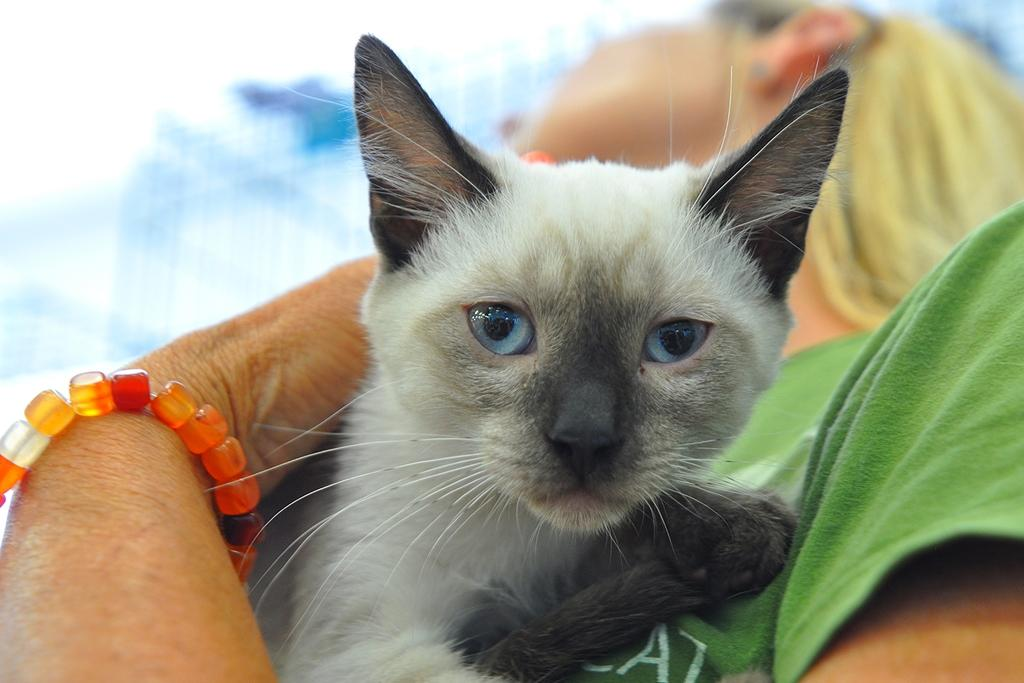What type of animal is in the picture? There is a white color cat in the picture. What is the cat doing in the picture? The cat is looking into the camera. Who is holding the cat in the picture? The cat is being held by a girl. How would you describe the background in the picture? The background in the picture is blurred. What type of doctor is attending to the nation in the picture? There is no doctor or nation present in the picture; it features a white color cat being held by a girl. 